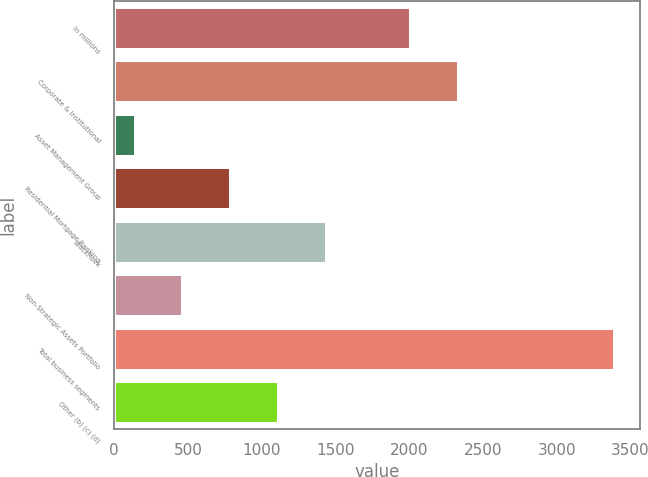Convert chart to OTSL. <chart><loc_0><loc_0><loc_500><loc_500><bar_chart><fcel>In millions<fcel>Corporate & Institutional<fcel>Asset Management Group<fcel>Residential Mortgage Banking<fcel>BlackRock<fcel>Non-Strategic Assets Portfolio<fcel>Total business segments<fcel>Other (b) (c) (d)<nl><fcel>2012<fcel>2336.8<fcel>145<fcel>794.6<fcel>1444.2<fcel>469.8<fcel>3393<fcel>1119.4<nl></chart> 